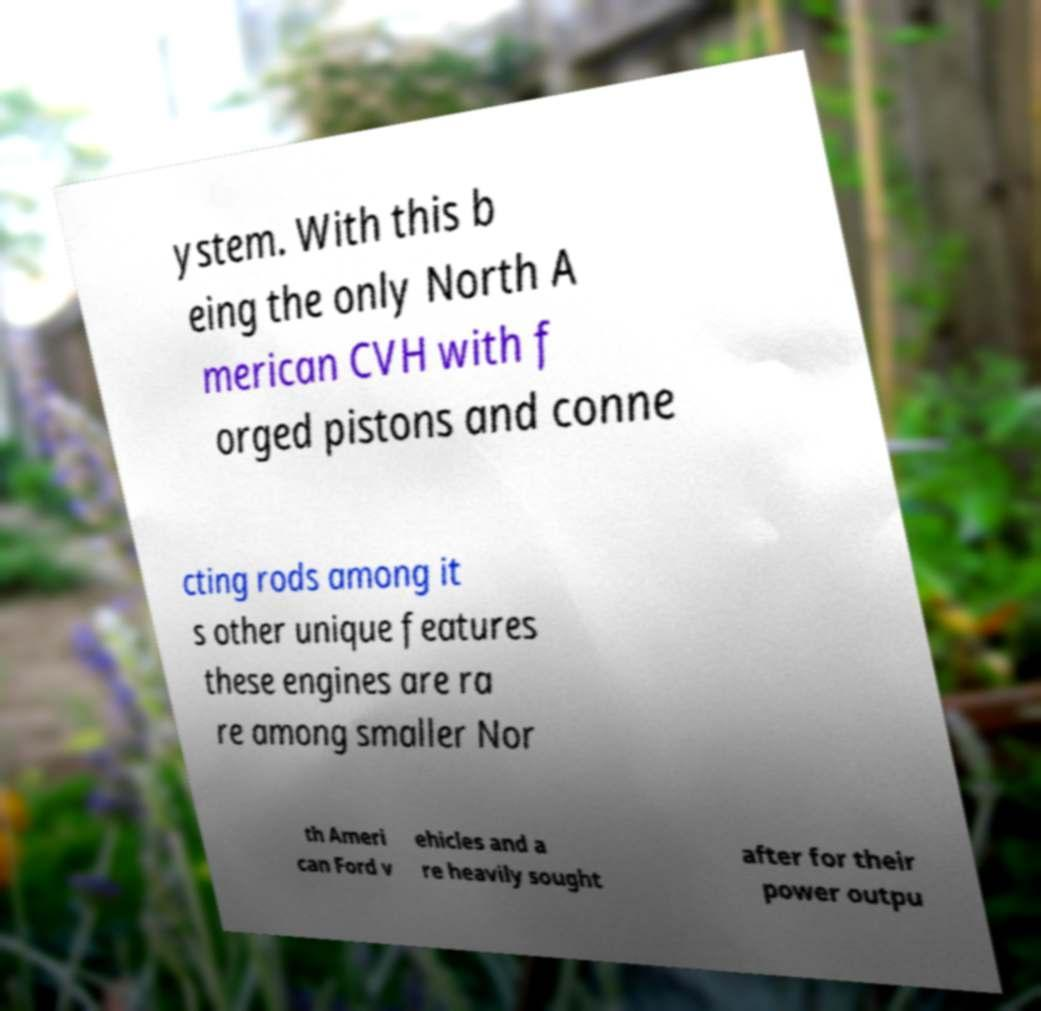There's text embedded in this image that I need extracted. Can you transcribe it verbatim? ystem. With this b eing the only North A merican CVH with f orged pistons and conne cting rods among it s other unique features these engines are ra re among smaller Nor th Ameri can Ford v ehicles and a re heavily sought after for their power outpu 